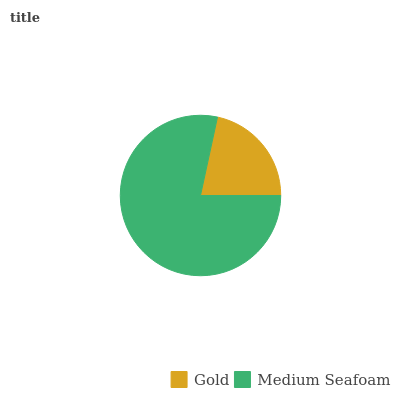Is Gold the minimum?
Answer yes or no. Yes. Is Medium Seafoam the maximum?
Answer yes or no. Yes. Is Medium Seafoam the minimum?
Answer yes or no. No. Is Medium Seafoam greater than Gold?
Answer yes or no. Yes. Is Gold less than Medium Seafoam?
Answer yes or no. Yes. Is Gold greater than Medium Seafoam?
Answer yes or no. No. Is Medium Seafoam less than Gold?
Answer yes or no. No. Is Medium Seafoam the high median?
Answer yes or no. Yes. Is Gold the low median?
Answer yes or no. Yes. Is Gold the high median?
Answer yes or no. No. Is Medium Seafoam the low median?
Answer yes or no. No. 